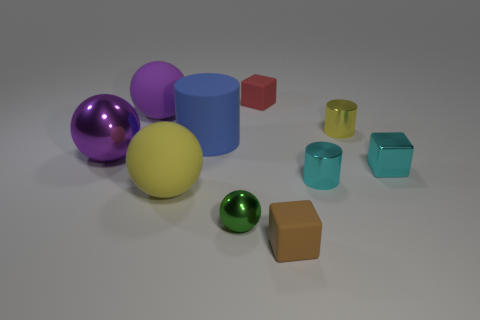What is the shape of the thing that is the same color as the large metallic ball?
Offer a terse response. Sphere. What number of other things are there of the same size as the red thing?
Make the answer very short. 5. There is a large yellow thing in front of the tiny cyan cube; is it the same shape as the large purple metal thing?
Offer a very short reply. Yes. Are there more tiny red rubber cubes right of the red matte thing than tiny yellow metal blocks?
Offer a very short reply. No. What is the small block that is both behind the tiny green object and right of the red matte thing made of?
Provide a succinct answer. Metal. Is there anything else that is the same shape as the tiny red matte object?
Ensure brevity in your answer.  Yes. What number of shiny things are both left of the brown block and right of the big shiny thing?
Make the answer very short. 1. What material is the blue cylinder?
Your answer should be very brief. Rubber. Are there the same number of small red cubes on the left side of the tiny green ball and big cubes?
Offer a terse response. Yes. What number of large metal objects have the same shape as the yellow matte thing?
Your answer should be very brief. 1. 